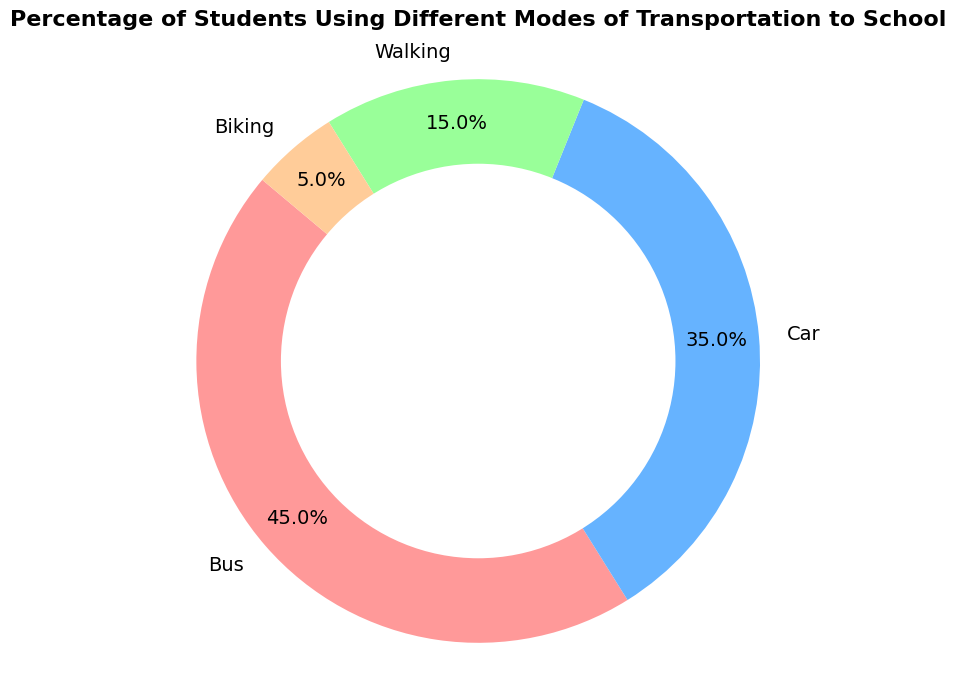What percentage of students use a car as their mode of transportation to school? The pie chart visually indicates that the section labeled "Car" represents 35% of the students. This is explicitly shown in the chart's labels and percentage annotations.
Answer: 35% Is the percentage of students who walk to school greater than those who bike? By examining the pie chart, the "Walking" section accounts for 15% of students, while the "Biking" section accounts for 5%. Clearly, 15% is greater than 5%.
Answer: Yes What is the combined percentage of students who either walk or bike to school? The pie chart shows 15% of students walk and 5% bike. Combined, they represent 15% + 5% = 20% of the students.
Answer: 20% Which mode of transportation has the highest percentage of students? From the pie chart, the "Bus" section, representing 45% of students, is the largest, indicating that the bus is the most common mode of transportation.
Answer: Bus What is the difference in the percentage of students using buses compared to cars? The pie chart shows 45% of students use buses and 35% use cars. The difference is 45% - 35% = 10%.
Answer: 10% What percentage of students use modes of transportation other than a bus? The bus section shows 45%, so students using other modes are represented by 100% - 45% = 55%.
Answer: 55% If you categorize modes of transportation into motorized (bus or car) and non-motorized (walking or biking), what is the percentage of students using non-motorized transportation? The pie chart indicates 15% of students walk, and 5% bike. So, non-motorized transportation usage is 15% + 5% = 20%.
Answer: 20% What color represents the segment for biking? The pie chart uses a distinct color scheme, and according to the information, the segment for biking is represented by a light orange color.
Answer: Light orange How does the percentage of students walking compare to the combined percentage of students biking and walking? The combined percentage for walking and biking is 15% + 5% = 20%. Walking alone is 15%, which is less than the combined percentage of 20%.
Answer: Less 